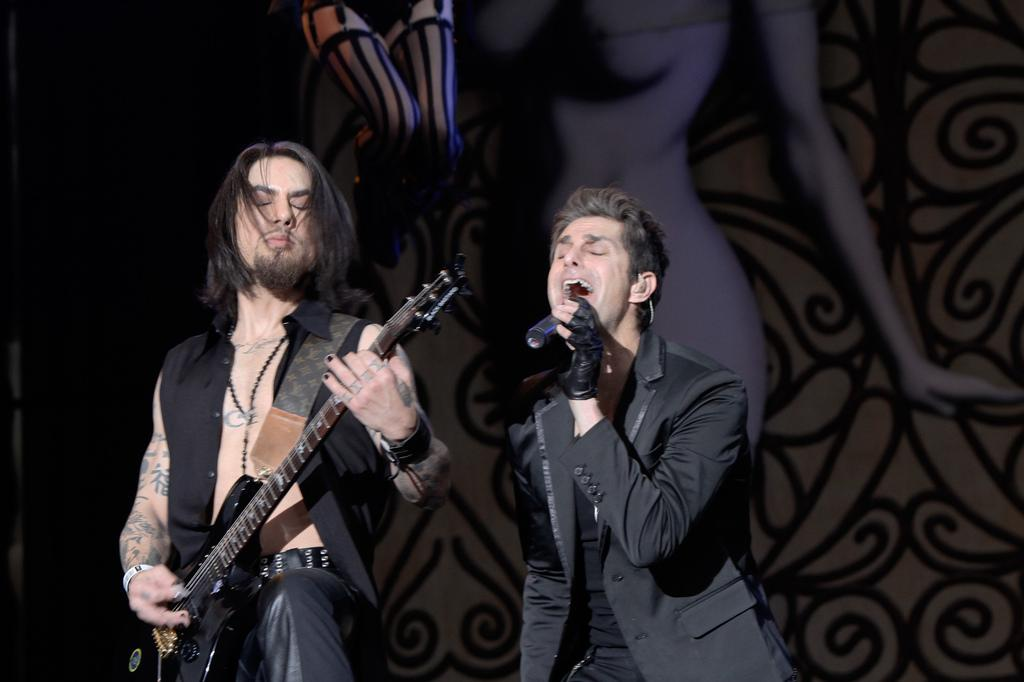What is the person on the right side of the image doing? The person on the right side is singing. What object is the person on the right side holding? The person on the right side is holding a microphone. What is the person on the left side of the image doing? The person on the left side is playing a guitar. What account number is associated with the person on the left side of the image? There is no account number mentioned or visible in the image. What thought is the person on the right side of the image having while singing? We cannot determine the person's thoughts from the image alone. --- Facts: 1. There is a person sitting on a chair in the image. 2. The person is reading a book. 3. The book has a blue cover. 4. The chair is made of wood. 5. There is a lamp on a table next to the chair. Absurd Topics: dance, ocean, laughter Conversation: What is the person in the image doing? The person is sitting on a chair and reading a book. What color is the book cover? The book cover is blue. What is the chair made of? The chair is made of wood. What object is on the table next to the chair? There is a lamp on the table next to the chair. Reasoning: Let's think step by step in order to produce the conversation. We start by identifying the main subject in the image, which is the person sitting on a chair. Then, we expand the conversation to include the person's activity (reading a book), the color of the book cover, the material of the chair, and the object on the table next to the chair. Each question is designed to elicit a specific detail about the image that is known from the provided facts. Absurd Question/Answer: Can you hear the laughter of the person reading the book in the image? There is no sound or indication of laughter in the image. Is the person dancing while reading the book in the image? There is no indication of dancing in the image; the person is sitting and reading. 